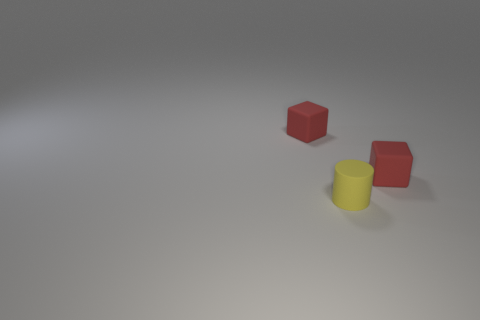What is the color of the small rubber cylinder?
Provide a succinct answer. Yellow. What number of things are tiny red blocks that are left of the yellow rubber cylinder or rubber objects?
Keep it short and to the point. 3. Does the yellow cylinder have the same material as the cube that is on the left side of the small yellow matte thing?
Provide a succinct answer. Yes. There is a matte object that is in front of the tiny red matte thing that is on the right side of the small cube on the left side of the tiny cylinder; what color is it?
Your answer should be very brief. Yellow. What number of tiny red objects have the same material as the tiny yellow cylinder?
Your answer should be compact. 2. There is a thing that is to the right of the yellow matte thing; is its size the same as the rubber cube to the left of the cylinder?
Make the answer very short. Yes. The small block that is on the left side of the small yellow rubber thing is what color?
Your answer should be compact. Red. There is a red rubber object that is to the right of the tiny red cube that is to the left of the red matte cube on the right side of the yellow thing; what size is it?
Provide a short and direct response. Small. There is a yellow rubber object; what number of matte objects are on the left side of it?
Give a very brief answer. 1. What number of things are either red rubber cubes to the left of the small rubber cylinder or things on the left side of the yellow matte cylinder?
Ensure brevity in your answer.  1. 